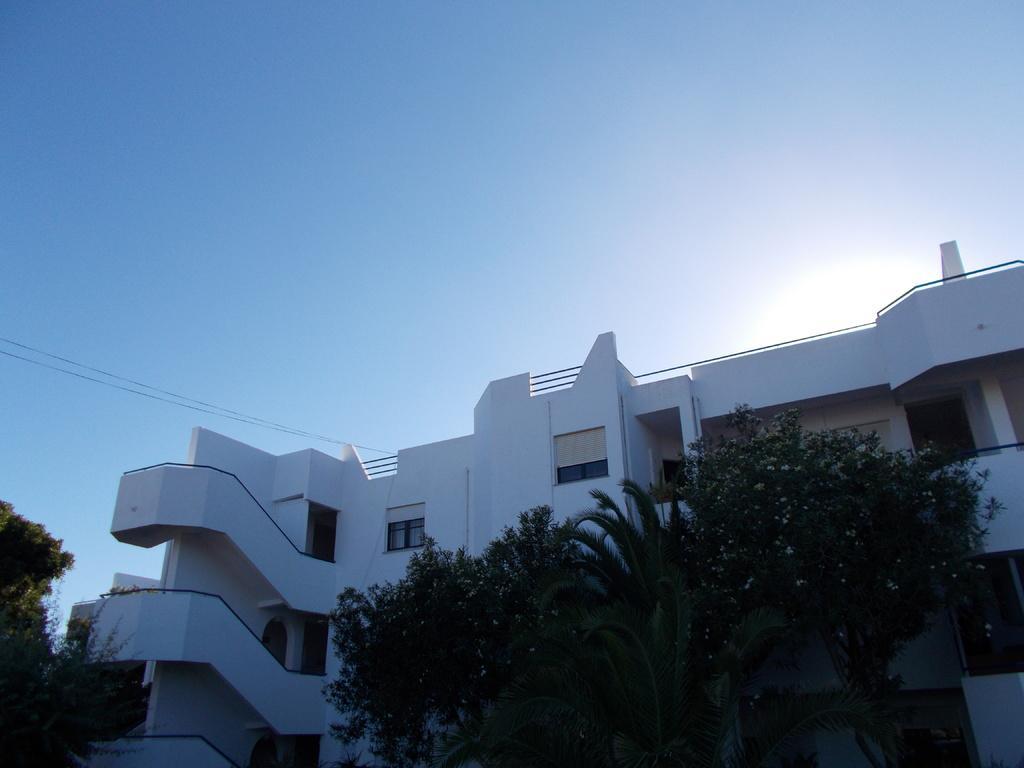Describe this image in one or two sentences. In this picture, there are trees at the bottom. Behind the trees, there is a building. At the top, there is a sky. 